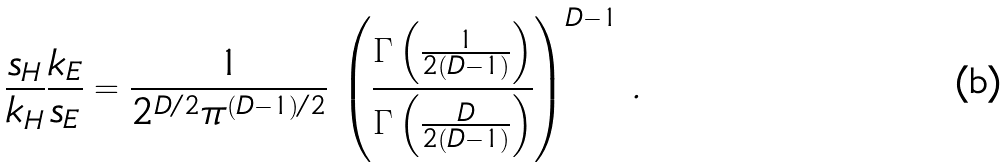Convert formula to latex. <formula><loc_0><loc_0><loc_500><loc_500>\frac { s _ { H } } { k _ { H } } \frac { k _ { E } } { s _ { E } } = \frac { 1 } { 2 ^ { D / 2 } \pi ^ { ( D - 1 ) / 2 } } \, \left ( \frac { \Gamma \left ( \frac { 1 } { 2 ( D - 1 ) } \right ) } { \Gamma \left ( \frac { D } { 2 ( D - 1 ) } \right ) } \right ) ^ { D - 1 } \, .</formula> 